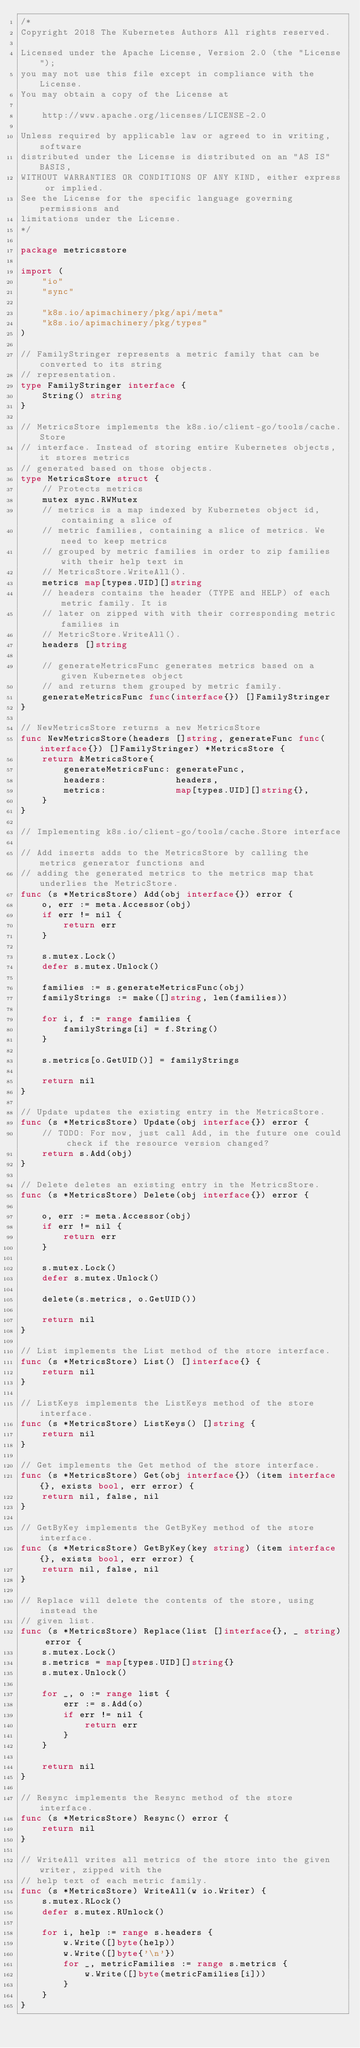<code> <loc_0><loc_0><loc_500><loc_500><_Go_>/*
Copyright 2018 The Kubernetes Authors All rights reserved.

Licensed under the Apache License, Version 2.0 (the "License");
you may not use this file except in compliance with the License.
You may obtain a copy of the License at

    http://www.apache.org/licenses/LICENSE-2.0

Unless required by applicable law or agreed to in writing, software
distributed under the License is distributed on an "AS IS" BASIS,
WITHOUT WARRANTIES OR CONDITIONS OF ANY KIND, either express or implied.
See the License for the specific language governing permissions and
limitations under the License.
*/

package metricsstore

import (
	"io"
	"sync"

	"k8s.io/apimachinery/pkg/api/meta"
	"k8s.io/apimachinery/pkg/types"
)

// FamilyStringer represents a metric family that can be converted to its string
// representation.
type FamilyStringer interface {
	String() string
}

// MetricsStore implements the k8s.io/client-go/tools/cache.Store
// interface. Instead of storing entire Kubernetes objects, it stores metrics
// generated based on those objects.
type MetricsStore struct {
	// Protects metrics
	mutex sync.RWMutex
	// metrics is a map indexed by Kubernetes object id, containing a slice of
	// metric families, containing a slice of metrics. We need to keep metrics
	// grouped by metric families in order to zip families with their help text in
	// MetricsStore.WriteAll().
	metrics map[types.UID][]string
	// headers contains the header (TYPE and HELP) of each metric family. It is
	// later on zipped with with their corresponding metric families in
	// MetricStore.WriteAll().
	headers []string

	// generateMetricsFunc generates metrics based on a given Kubernetes object
	// and returns them grouped by metric family.
	generateMetricsFunc func(interface{}) []FamilyStringer
}

// NewMetricsStore returns a new MetricsStore
func NewMetricsStore(headers []string, generateFunc func(interface{}) []FamilyStringer) *MetricsStore {
	return &MetricsStore{
		generateMetricsFunc: generateFunc,
		headers:             headers,
		metrics:             map[types.UID][]string{},
	}
}

// Implementing k8s.io/client-go/tools/cache.Store interface

// Add inserts adds to the MetricsStore by calling the metrics generator functions and
// adding the generated metrics to the metrics map that underlies the MetricStore.
func (s *MetricsStore) Add(obj interface{}) error {
	o, err := meta.Accessor(obj)
	if err != nil {
		return err
	}

	s.mutex.Lock()
	defer s.mutex.Unlock()

	families := s.generateMetricsFunc(obj)
	familyStrings := make([]string, len(families))

	for i, f := range families {
		familyStrings[i] = f.String()
	}

	s.metrics[o.GetUID()] = familyStrings

	return nil
}

// Update updates the existing entry in the MetricsStore.
func (s *MetricsStore) Update(obj interface{}) error {
	// TODO: For now, just call Add, in the future one could check if the resource version changed?
	return s.Add(obj)
}

// Delete deletes an existing entry in the MetricsStore.
func (s *MetricsStore) Delete(obj interface{}) error {

	o, err := meta.Accessor(obj)
	if err != nil {
		return err
	}

	s.mutex.Lock()
	defer s.mutex.Unlock()

	delete(s.metrics, o.GetUID())

	return nil
}

// List implements the List method of the store interface.
func (s *MetricsStore) List() []interface{} {
	return nil
}

// ListKeys implements the ListKeys method of the store interface.
func (s *MetricsStore) ListKeys() []string {
	return nil
}

// Get implements the Get method of the store interface.
func (s *MetricsStore) Get(obj interface{}) (item interface{}, exists bool, err error) {
	return nil, false, nil
}

// GetByKey implements the GetByKey method of the store interface.
func (s *MetricsStore) GetByKey(key string) (item interface{}, exists bool, err error) {
	return nil, false, nil
}

// Replace will delete the contents of the store, using instead the
// given list.
func (s *MetricsStore) Replace(list []interface{}, _ string) error {
	s.mutex.Lock()
	s.metrics = map[types.UID][]string{}
	s.mutex.Unlock()

	for _, o := range list {
		err := s.Add(o)
		if err != nil {
			return err
		}
	}

	return nil
}

// Resync implements the Resync method of the store interface.
func (s *MetricsStore) Resync() error {
	return nil
}

// WriteAll writes all metrics of the store into the given writer, zipped with the
// help text of each metric family.
func (s *MetricsStore) WriteAll(w io.Writer) {
	s.mutex.RLock()
	defer s.mutex.RUnlock()

	for i, help := range s.headers {
		w.Write([]byte(help))
		w.Write([]byte{'\n'})
		for _, metricFamilies := range s.metrics {
			w.Write([]byte(metricFamilies[i]))
		}
	}
}
</code> 